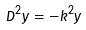Convert formula to latex. <formula><loc_0><loc_0><loc_500><loc_500>D ^ { 2 } y = - k ^ { 2 } y</formula> 